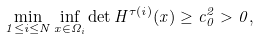<formula> <loc_0><loc_0><loc_500><loc_500>\min _ { 1 \leq i \leq N } \inf _ { x \in \Omega _ { i } } \det H ^ { \tau ( i ) } ( x ) \geq c _ { 0 } ^ { 2 } > 0 ,</formula> 